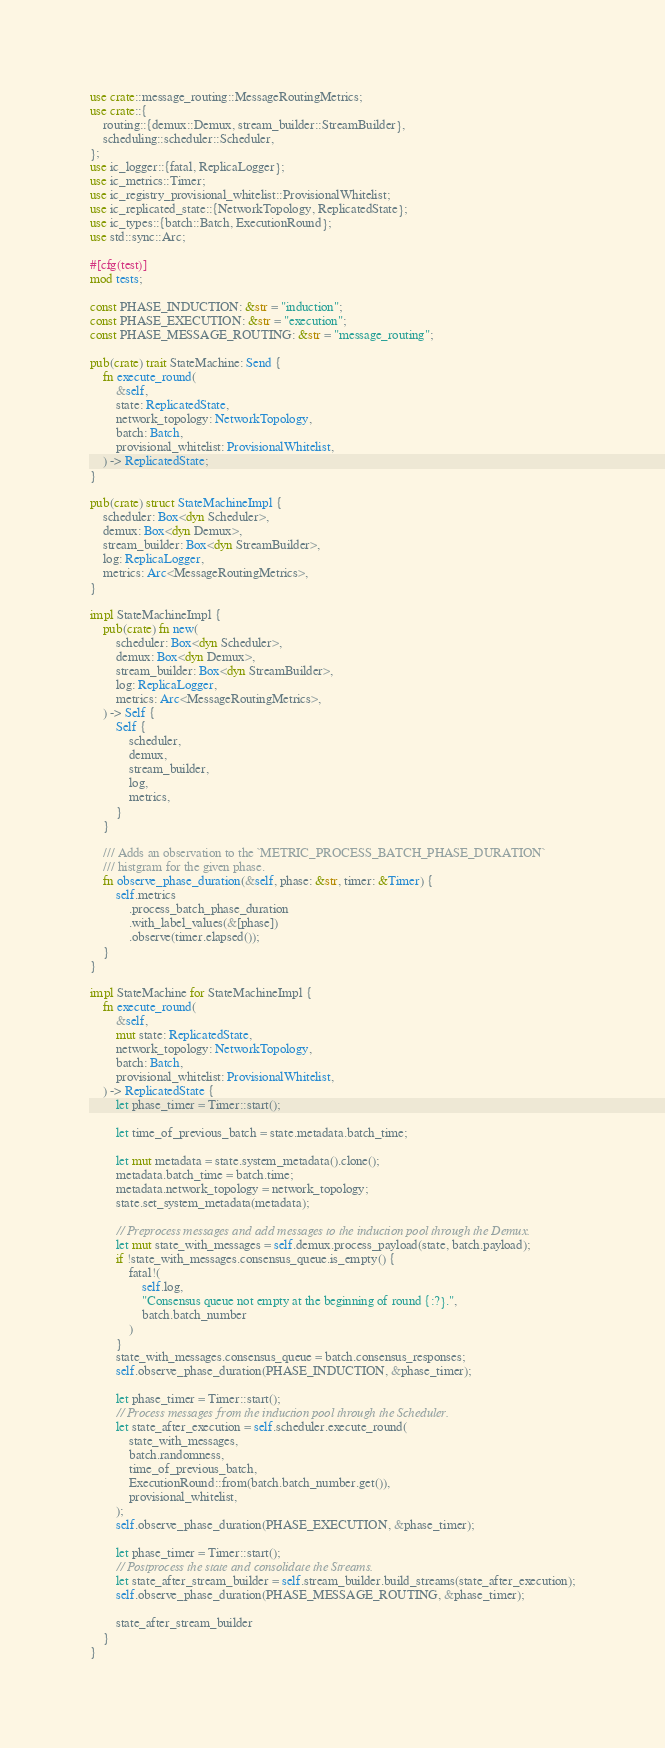Convert code to text. <code><loc_0><loc_0><loc_500><loc_500><_Rust_>use crate::message_routing::MessageRoutingMetrics;
use crate::{
    routing::{demux::Demux, stream_builder::StreamBuilder},
    scheduling::scheduler::Scheduler,
};
use ic_logger::{fatal, ReplicaLogger};
use ic_metrics::Timer;
use ic_registry_provisional_whitelist::ProvisionalWhitelist;
use ic_replicated_state::{NetworkTopology, ReplicatedState};
use ic_types::{batch::Batch, ExecutionRound};
use std::sync::Arc;

#[cfg(test)]
mod tests;

const PHASE_INDUCTION: &str = "induction";
const PHASE_EXECUTION: &str = "execution";
const PHASE_MESSAGE_ROUTING: &str = "message_routing";

pub(crate) trait StateMachine: Send {
    fn execute_round(
        &self,
        state: ReplicatedState,
        network_topology: NetworkTopology,
        batch: Batch,
        provisional_whitelist: ProvisionalWhitelist,
    ) -> ReplicatedState;
}

pub(crate) struct StateMachineImpl {
    scheduler: Box<dyn Scheduler>,
    demux: Box<dyn Demux>,
    stream_builder: Box<dyn StreamBuilder>,
    log: ReplicaLogger,
    metrics: Arc<MessageRoutingMetrics>,
}

impl StateMachineImpl {
    pub(crate) fn new(
        scheduler: Box<dyn Scheduler>,
        demux: Box<dyn Demux>,
        stream_builder: Box<dyn StreamBuilder>,
        log: ReplicaLogger,
        metrics: Arc<MessageRoutingMetrics>,
    ) -> Self {
        Self {
            scheduler,
            demux,
            stream_builder,
            log,
            metrics,
        }
    }

    /// Adds an observation to the `METRIC_PROCESS_BATCH_PHASE_DURATION`
    /// histgram for the given phase.
    fn observe_phase_duration(&self, phase: &str, timer: &Timer) {
        self.metrics
            .process_batch_phase_duration
            .with_label_values(&[phase])
            .observe(timer.elapsed());
    }
}

impl StateMachine for StateMachineImpl {
    fn execute_round(
        &self,
        mut state: ReplicatedState,
        network_topology: NetworkTopology,
        batch: Batch,
        provisional_whitelist: ProvisionalWhitelist,
    ) -> ReplicatedState {
        let phase_timer = Timer::start();

        let time_of_previous_batch = state.metadata.batch_time;

        let mut metadata = state.system_metadata().clone();
        metadata.batch_time = batch.time;
        metadata.network_topology = network_topology;
        state.set_system_metadata(metadata);

        // Preprocess messages and add messages to the induction pool through the Demux.
        let mut state_with_messages = self.demux.process_payload(state, batch.payload);
        if !state_with_messages.consensus_queue.is_empty() {
            fatal!(
                self.log,
                "Consensus queue not empty at the beginning of round {:?}.",
                batch.batch_number
            )
        }
        state_with_messages.consensus_queue = batch.consensus_responses;
        self.observe_phase_duration(PHASE_INDUCTION, &phase_timer);

        let phase_timer = Timer::start();
        // Process messages from the induction pool through the Scheduler.
        let state_after_execution = self.scheduler.execute_round(
            state_with_messages,
            batch.randomness,
            time_of_previous_batch,
            ExecutionRound::from(batch.batch_number.get()),
            provisional_whitelist,
        );
        self.observe_phase_duration(PHASE_EXECUTION, &phase_timer);

        let phase_timer = Timer::start();
        // Postprocess the state and consolidate the Streams.
        let state_after_stream_builder = self.stream_builder.build_streams(state_after_execution);
        self.observe_phase_duration(PHASE_MESSAGE_ROUTING, &phase_timer);

        state_after_stream_builder
    }
}
</code> 